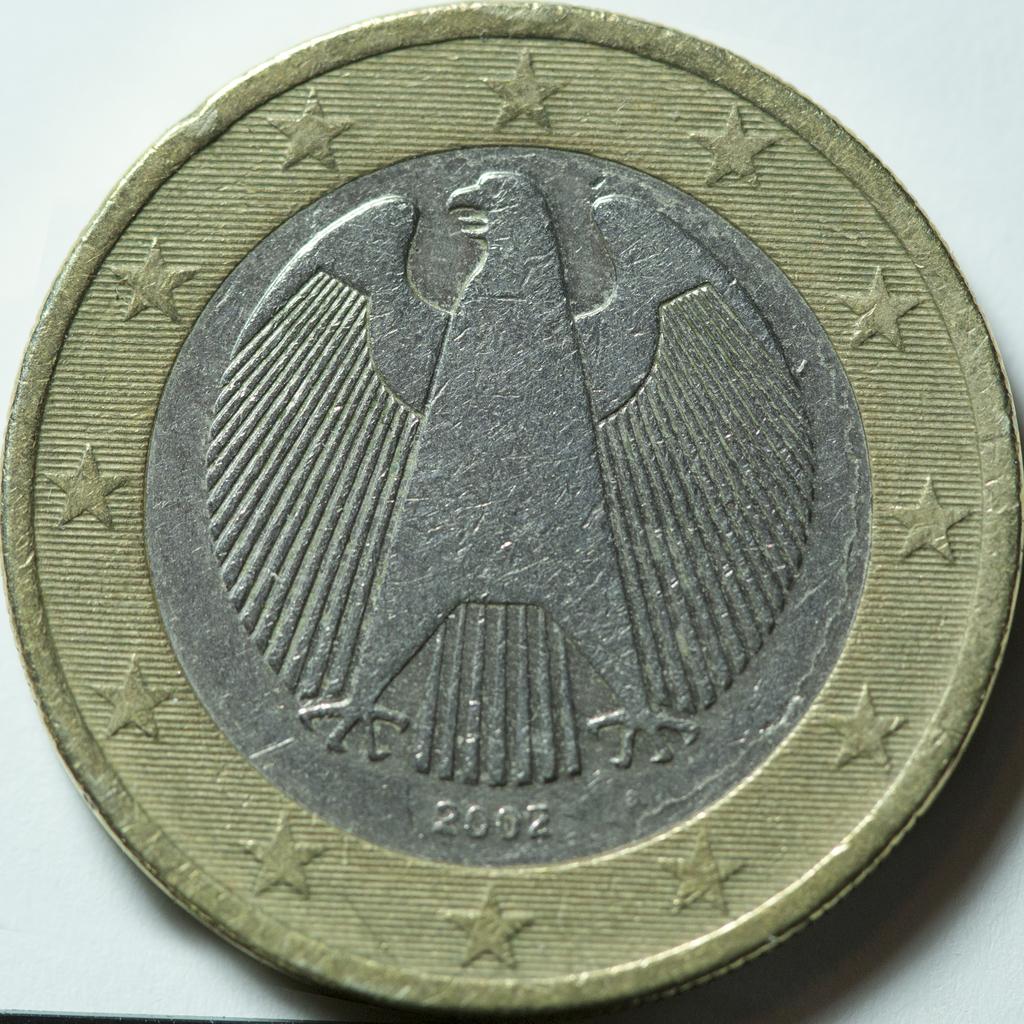What is the year on the coin?
Provide a short and direct response. 2002. How many individual numbers are on the coin?
Your answer should be compact. 4. 